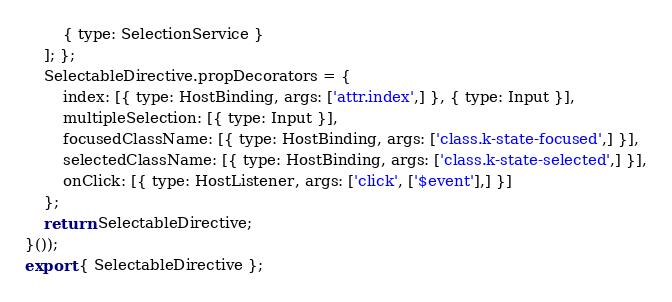<code> <loc_0><loc_0><loc_500><loc_500><_JavaScript_>        { type: SelectionService }
    ]; };
    SelectableDirective.propDecorators = {
        index: [{ type: HostBinding, args: ['attr.index',] }, { type: Input }],
        multipleSelection: [{ type: Input }],
        focusedClassName: [{ type: HostBinding, args: ['class.k-state-focused',] }],
        selectedClassName: [{ type: HostBinding, args: ['class.k-state-selected',] }],
        onClick: [{ type: HostListener, args: ['click', ['$event'],] }]
    };
    return SelectableDirective;
}());
export { SelectableDirective };
</code> 